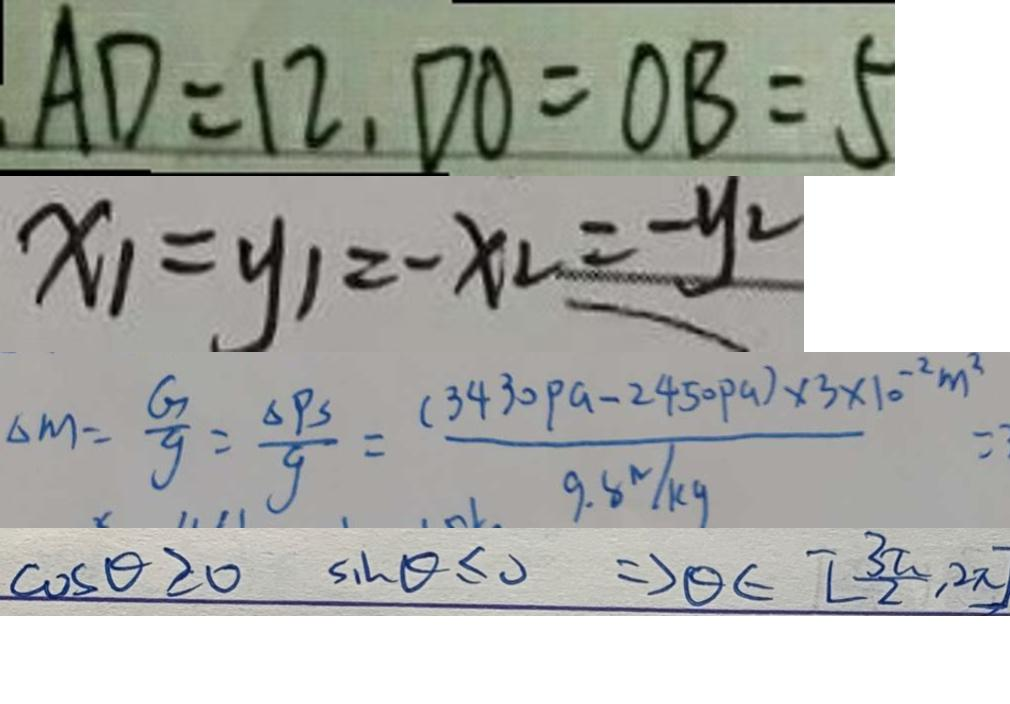<formula> <loc_0><loc_0><loc_500><loc_500>A D = 1 2 , D O = O B = 5 
 x _ { 1 } = y _ { 1 } = - x _ { 2 } = - y _ { 2 } 
 \Delta m = \frac { G } { g } = \frac { \Delta P S } { g } = \frac { ( 3 4 3 0 p a - 2 4 5 0 p a ) \times 3 \times 1 0 ^ { - 2 } m ^ { 2 } } { 9 . 8 N / k g } = 
 \cos \theta \geq 0 \sin \theta \leq 0 \Rightarrow \theta \in [ \frac { 3 \pi } { 2 } , 2 \pi ]</formula> 